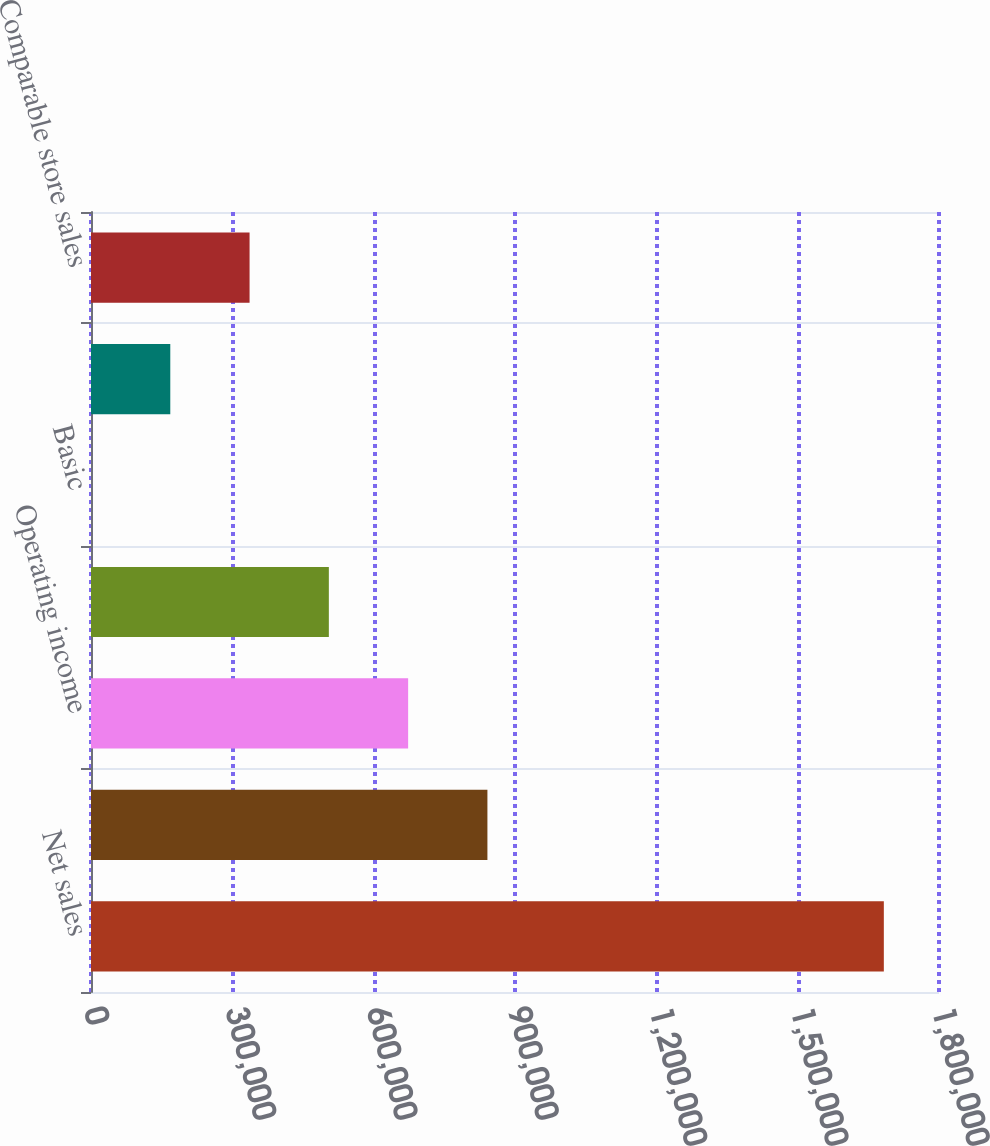Convert chart. <chart><loc_0><loc_0><loc_500><loc_500><bar_chart><fcel>Net sales<fcel>Gross profit<fcel>Operating income<fcel>Net income<fcel>Basic<fcel>Diluted<fcel>Comparable store sales<nl><fcel>1.6829e+06<fcel>841451<fcel>673161<fcel>504871<fcel>0.57<fcel>168291<fcel>336581<nl></chart> 